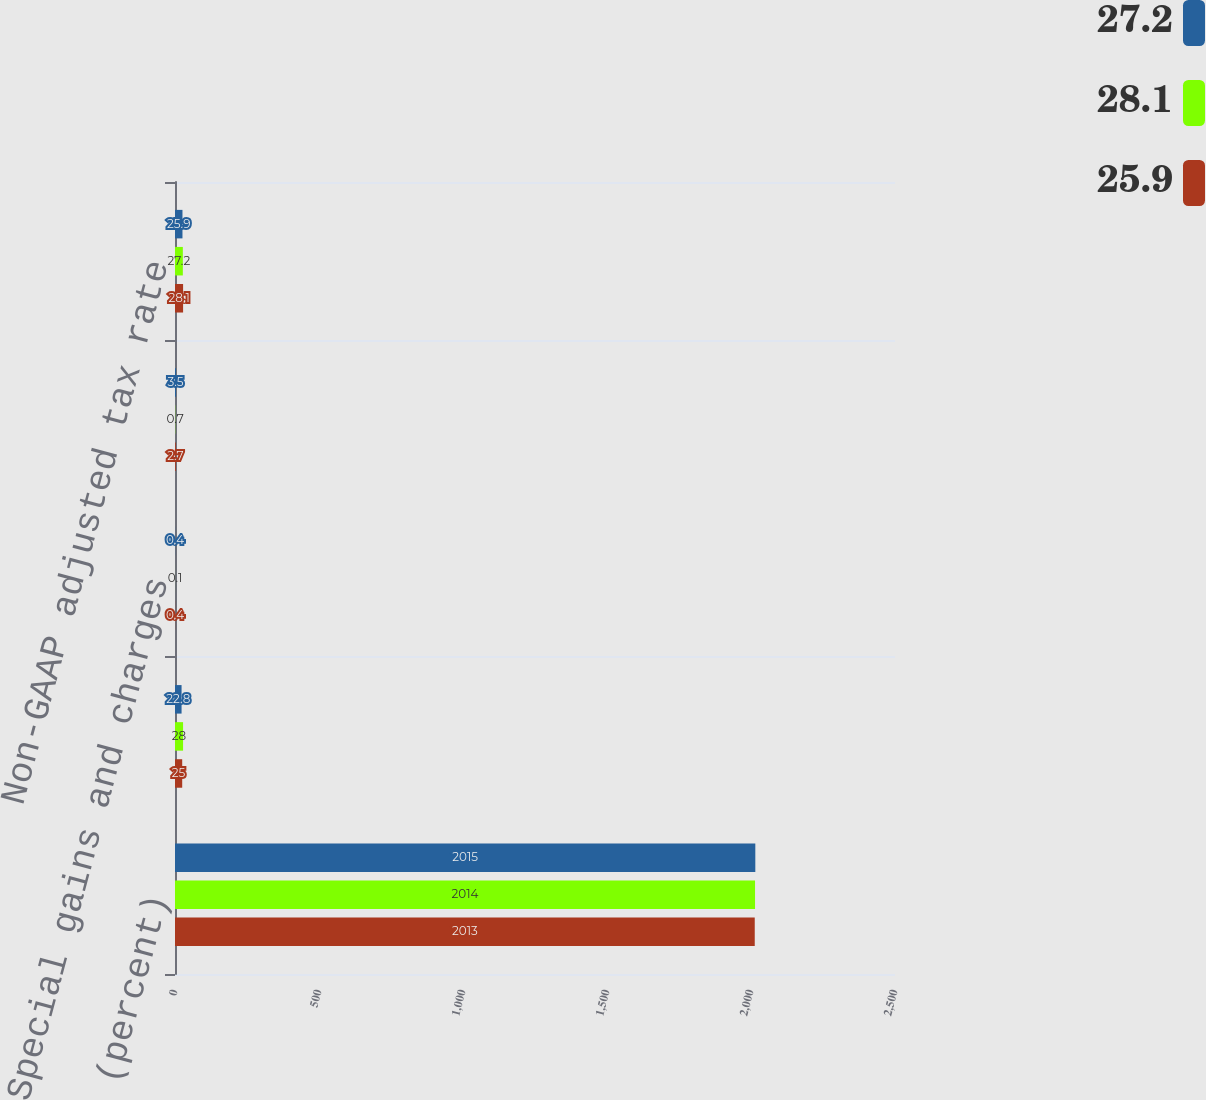<chart> <loc_0><loc_0><loc_500><loc_500><stacked_bar_chart><ecel><fcel>(percent)<fcel>Reported GAAP tax rate<fcel>Special gains and charges<fcel>Discrete tax items<fcel>Non-GAAP adjusted tax rate<nl><fcel>27.2<fcel>2015<fcel>22.8<fcel>0.4<fcel>3.5<fcel>25.9<nl><fcel>28.1<fcel>2014<fcel>28<fcel>0.1<fcel>0.7<fcel>27.2<nl><fcel>25.9<fcel>2013<fcel>25<fcel>0.4<fcel>2.7<fcel>28.1<nl></chart> 